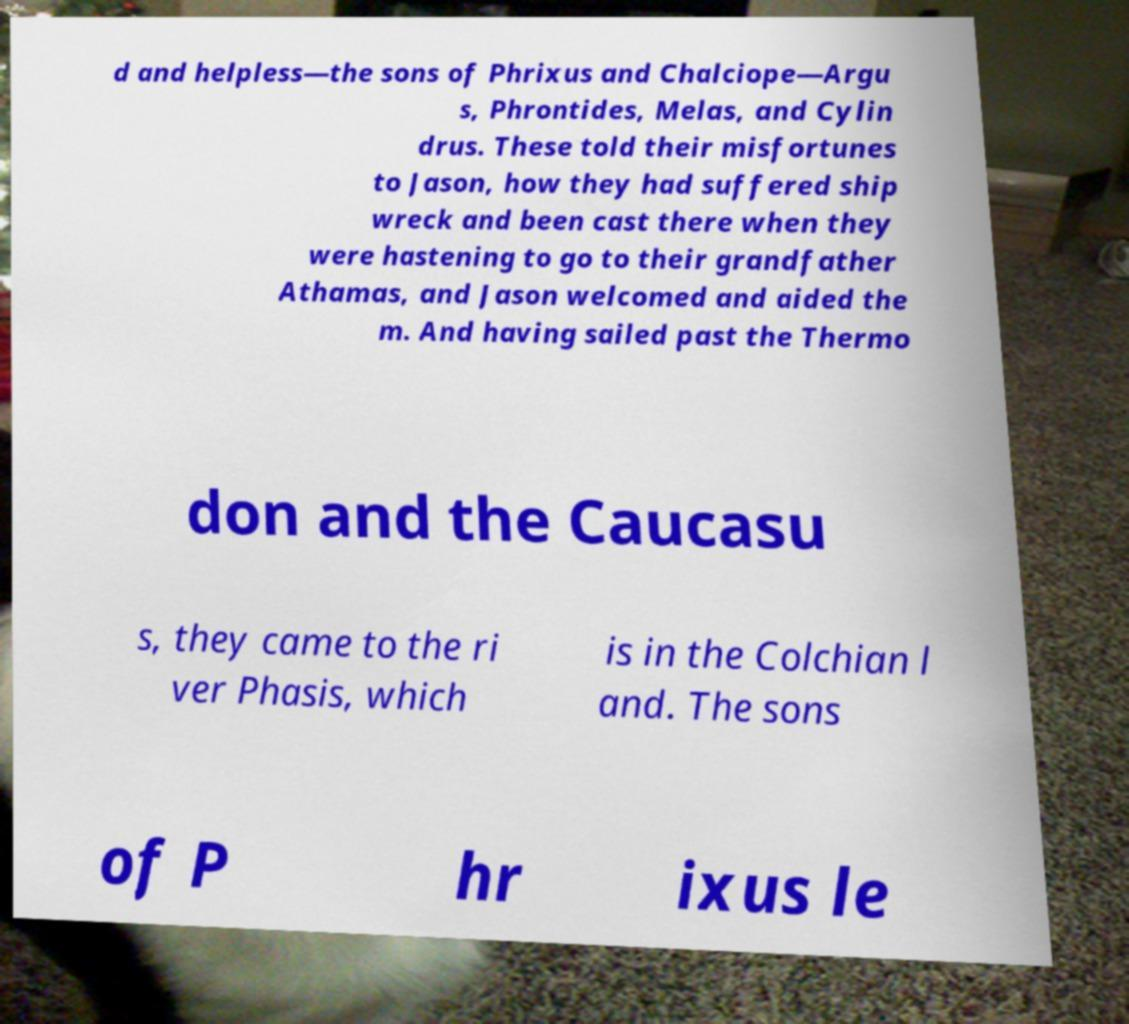Can you accurately transcribe the text from the provided image for me? d and helpless—the sons of Phrixus and Chalciope—Argu s, Phrontides, Melas, and Cylin drus. These told their misfortunes to Jason, how they had suffered ship wreck and been cast there when they were hastening to go to their grandfather Athamas, and Jason welcomed and aided the m. And having sailed past the Thermo don and the Caucasu s, they came to the ri ver Phasis, which is in the Colchian l and. The sons of P hr ixus le 